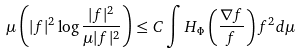Convert formula to latex. <formula><loc_0><loc_0><loc_500><loc_500>\mu \left ( | f | ^ { 2 } \log \frac { | f | ^ { 2 } } { \mu | f | ^ { 2 } } \right ) \leq C \int H _ { \Phi } \left ( \frac { \nabla f } { f } \right ) f ^ { 2 } d \mu</formula> 